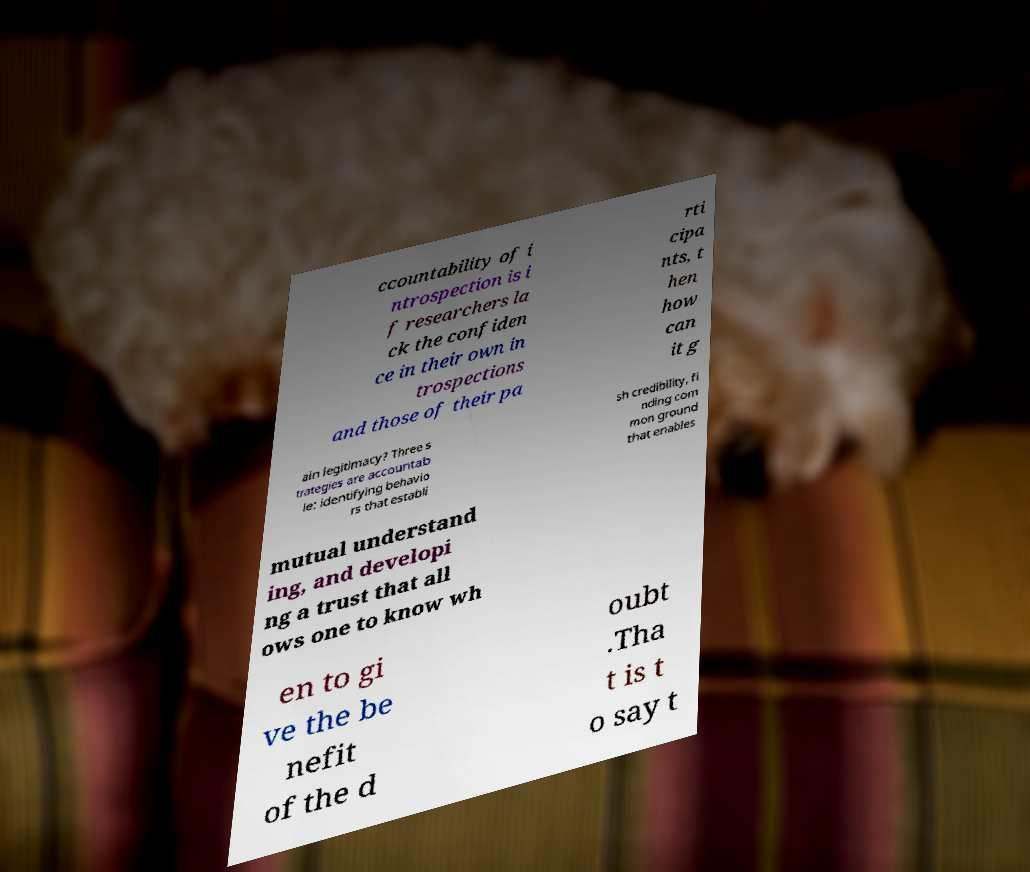For documentation purposes, I need the text within this image transcribed. Could you provide that? ccountability of i ntrospection is i f researchers la ck the confiden ce in their own in trospections and those of their pa rti cipa nts, t hen how can it g ain legitimacy? Three s trategies are accountab le: identifying behavio rs that establi sh credibility, fi nding com mon ground that enables mutual understand ing, and developi ng a trust that all ows one to know wh en to gi ve the be nefit of the d oubt .Tha t is t o say t 